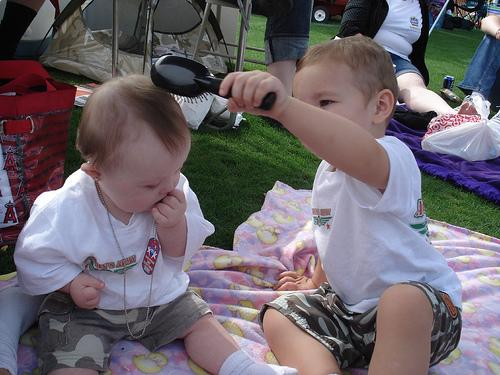What syndrome does the baby on the left have? Please explain your reasoning. down's syndrome. The facial characteristics are evident in the child's face. 